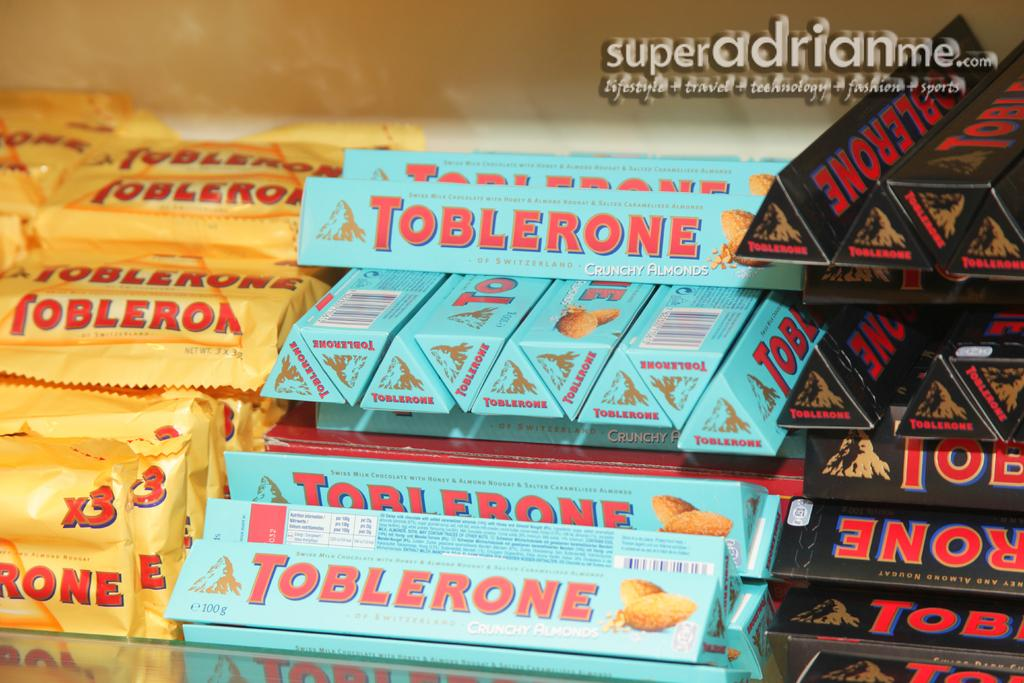<image>
Share a concise interpretation of the image provided. Three different varieties of Toblerone chocolate are arranged in a store display. 